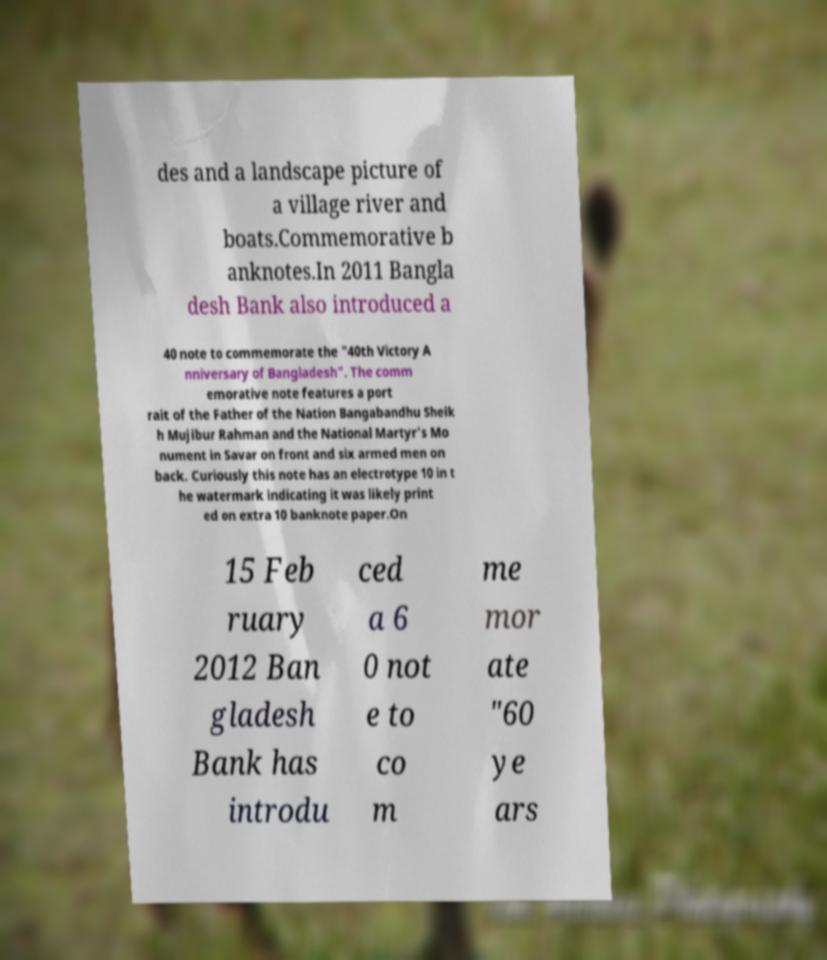Can you read and provide the text displayed in the image?This photo seems to have some interesting text. Can you extract and type it out for me? des and a landscape picture of a village river and boats.Commemorative b anknotes.In 2011 Bangla desh Bank also introduced a 40 note to commemorate the "40th Victory A nniversary of Bangladesh". The comm emorative note features a port rait of the Father of the Nation Bangabandhu Sheik h Mujibur Rahman and the National Martyr's Mo nument in Savar on front and six armed men on back. Curiously this note has an electrotype 10 in t he watermark indicating it was likely print ed on extra 10 banknote paper.On 15 Feb ruary 2012 Ban gladesh Bank has introdu ced a 6 0 not e to co m me mor ate "60 ye ars 